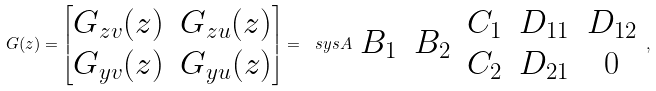<formula> <loc_0><loc_0><loc_500><loc_500>G ( z ) = \begin{bmatrix} G _ { z v } ( z ) & G _ { z u } ( z ) \\ G _ { y v } ( z ) & G _ { y u } ( z ) \end{bmatrix} = \ s y s { A } { \begin{array} { c c } B _ { 1 } & B _ { 2 } \end{array} } { \begin{array} { c } C _ { 1 } \\ C _ { 2 } \end{array} } { \begin{array} { c c } D _ { 1 1 } & D _ { 1 2 } \\ D _ { 2 1 } & 0 \end{array} } ,</formula> 